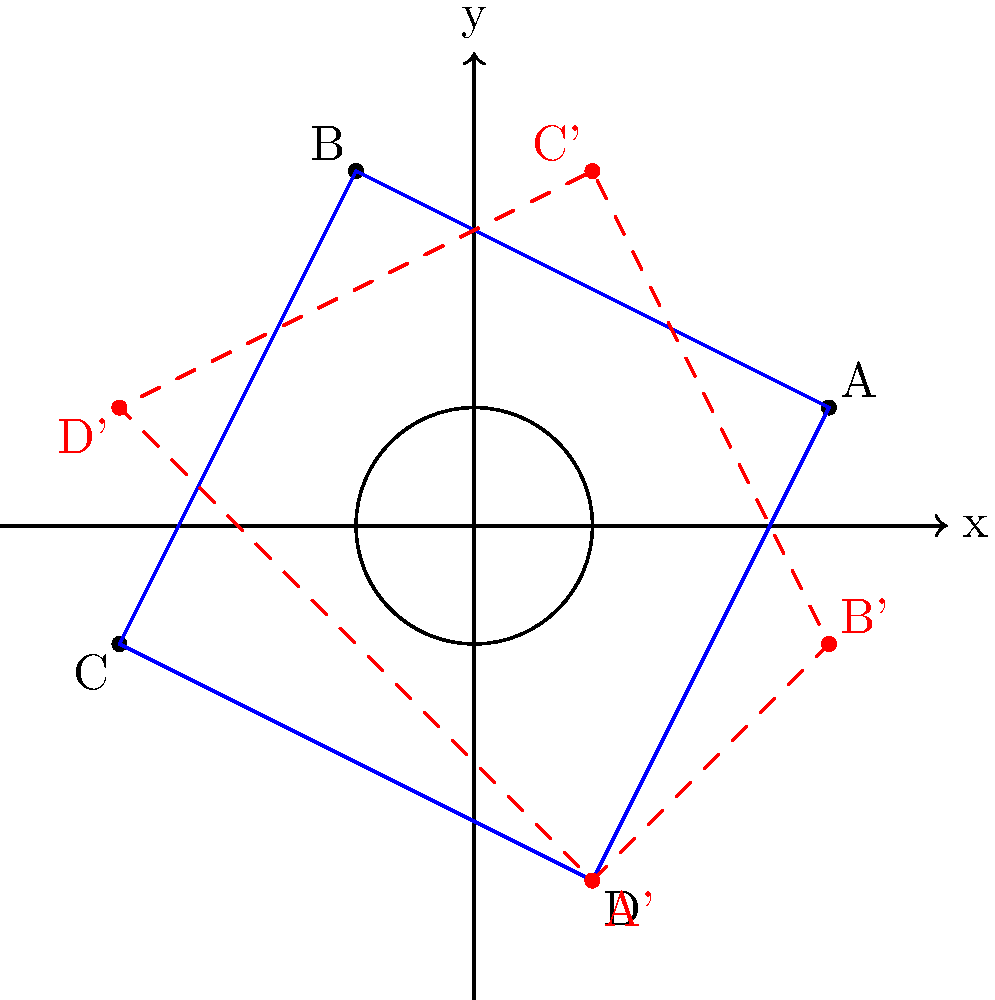In our ancestral lands, we often use geometric patterns in our traditional designs. Consider a square ABCD with vertices A(3,1), B(-1,3), C(-3,-1), and D(1,-3). If we rotate this square by 90° clockwise around the origin, what will be the coordinates of the rotated vertex A'? To solve this problem, let's follow these steps:

1) First, recall the formula for rotating a point (x,y) by 90° clockwise around the origin:
   $$(x,y) \rightarrow (y,-x)$$

2) The original coordinates of point A are (3,1).

3) Applying the rotation formula:
   $x_{new} = y_{old} = 1$
   $y_{new} = -x_{old} = -3$

4) Therefore, after rotation, point A moves to (1,-3).

5) We can verify this by looking at the diagram. The blue square ABCD is rotated 90° clockwise to form the red dashed square A'B'C'D'.

6) Indeed, we can see that A' is at position (1,-3) in the rotated square.

This method of rotation is crucial in our traditional designs, as it allows us to create complex patterns by rotating simple shapes.
Answer: (1,-3) 